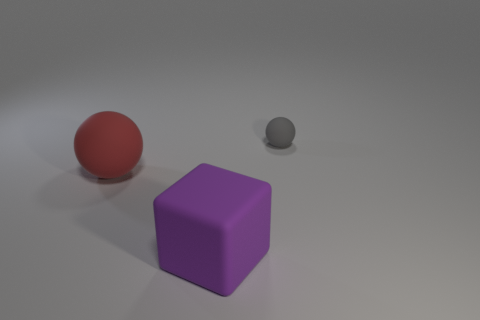Does the sphere in front of the gray sphere have the same material as the tiny gray object?
Provide a succinct answer. Yes. What is the color of the large thing that is the same shape as the tiny gray thing?
Your answer should be compact. Red. What number of other objects are there of the same color as the large cube?
Provide a succinct answer. 0. Do the tiny gray matte thing right of the red ball and the large object that is behind the large purple rubber object have the same shape?
Ensure brevity in your answer.  Yes. What number of spheres are yellow shiny objects or gray matte things?
Your response must be concise. 1. Is the number of big red balls behind the gray rubber object less than the number of green blocks?
Your answer should be very brief. No. How many other things are the same material as the big block?
Ensure brevity in your answer.  2. Do the gray rubber sphere and the matte block have the same size?
Provide a succinct answer. No. What number of things are either things in front of the large rubber sphere or small spheres?
Provide a short and direct response. 2. There is a ball that is left of the rubber object behind the large ball; what is its material?
Provide a short and direct response. Rubber. 